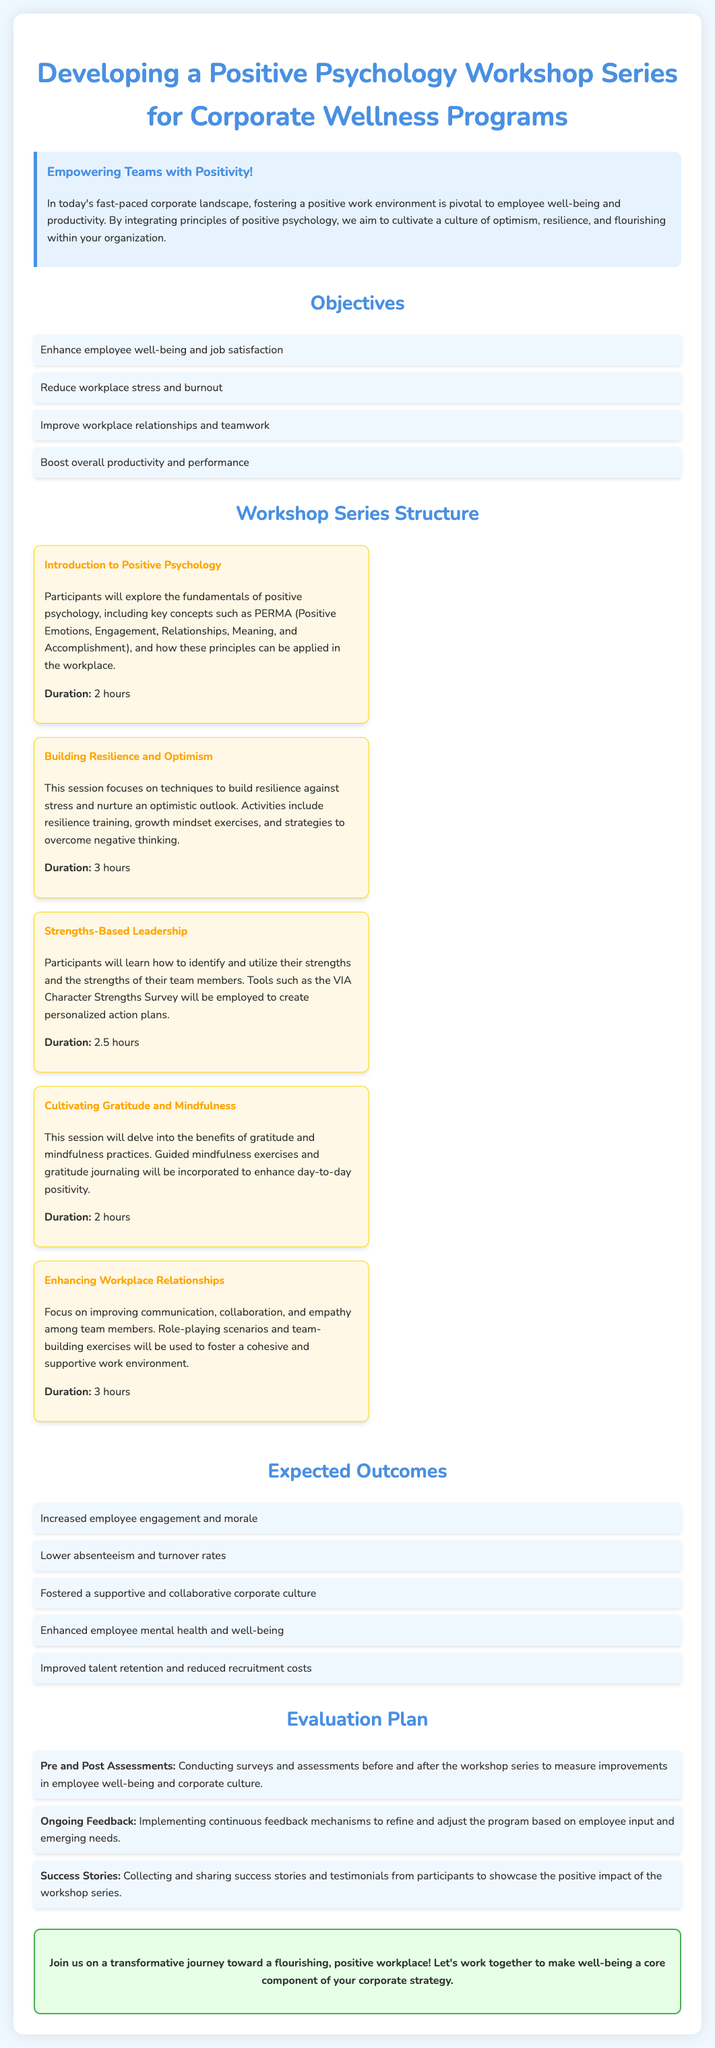what is the title of the proposal? The title is presented in the header of the document.
Answer: Developing a Positive Psychology Workshop Series for Corporate Wellness Programs what is the duration of the "Building Resilience and Optimism" session? The duration is mentioned in the description of the workshop session.
Answer: 3 hours how many workshop sessions are proposed in total? The number of workshop sessions is calculated by counting each listed session in the workshop series.
Answer: 5 what is the main objective of the workshop series? The document lists several objectives, but the main one related to well-being is emphasized.
Answer: Enhance employee well-being and job satisfaction which session focuses on communication and collaboration? This session title is referenced in the workshop series structure section.
Answer: Enhancing Workplace Relationships what type of assessments are conducted before and after the workshop series? The evaluation plan mentions the specific assessments used to gauge effectiveness.
Answer: Pre and Post Assessments what is one expected outcome of the workshop series related to employee retention? The expected outcomes section outlines benefits tied to retention.
Answer: Improved talent retention and reduced recruitment costs what feedback mechanism will be used to enhance the workshop? The evaluation plan discusses a type of feedback that is ongoing.
Answer: Ongoing Feedback what is the overall goal for the corporate strategy mentioned in the conclusion? The concluding section emphasizes the primary aim for corporate strategy.
Answer: Make well-being a core component of your corporate strategy 